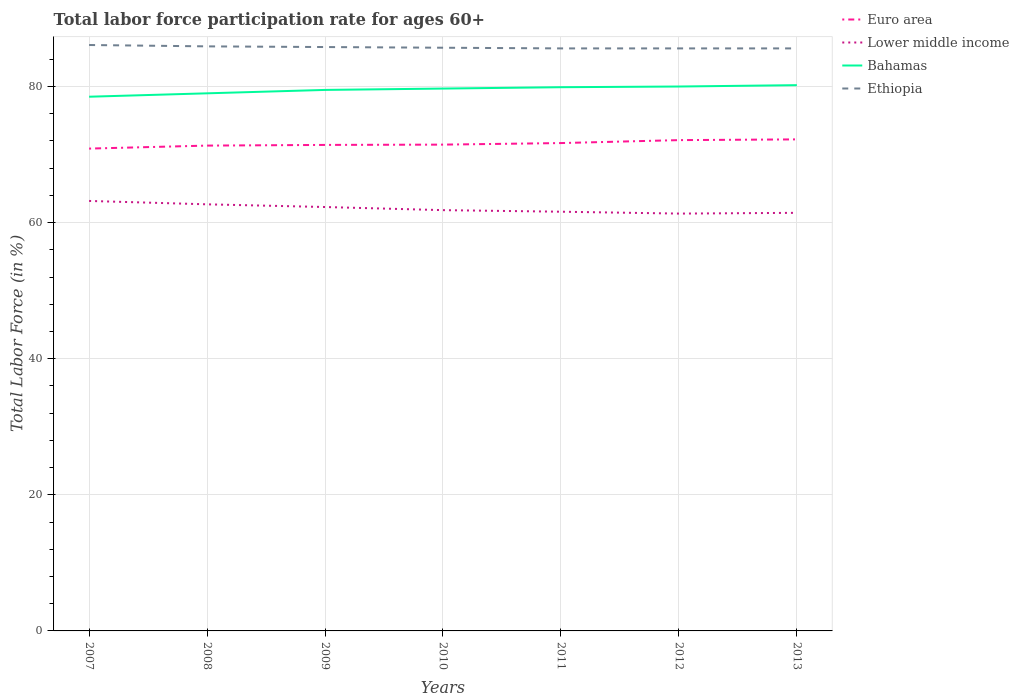How many different coloured lines are there?
Ensure brevity in your answer.  4. Across all years, what is the maximum labor force participation rate in Euro area?
Give a very brief answer. 70.88. In which year was the labor force participation rate in Lower middle income maximum?
Give a very brief answer. 2012. What is the total labor force participation rate in Euro area in the graph?
Your answer should be compact. -0.58. What is the difference between the highest and the second highest labor force participation rate in Bahamas?
Give a very brief answer. 1.7. What is the difference between two consecutive major ticks on the Y-axis?
Ensure brevity in your answer.  20. Are the values on the major ticks of Y-axis written in scientific E-notation?
Provide a succinct answer. No. Does the graph contain grids?
Your response must be concise. Yes. Where does the legend appear in the graph?
Offer a very short reply. Top right. What is the title of the graph?
Keep it short and to the point. Total labor force participation rate for ages 60+. Does "Lesotho" appear as one of the legend labels in the graph?
Your response must be concise. No. What is the label or title of the Y-axis?
Your answer should be very brief. Total Labor Force (in %). What is the Total Labor Force (in %) in Euro area in 2007?
Offer a terse response. 70.88. What is the Total Labor Force (in %) of Lower middle income in 2007?
Give a very brief answer. 63.19. What is the Total Labor Force (in %) of Bahamas in 2007?
Provide a short and direct response. 78.5. What is the Total Labor Force (in %) of Ethiopia in 2007?
Your answer should be very brief. 86.1. What is the Total Labor Force (in %) in Euro area in 2008?
Your response must be concise. 71.32. What is the Total Labor Force (in %) in Lower middle income in 2008?
Your response must be concise. 62.69. What is the Total Labor Force (in %) of Bahamas in 2008?
Provide a short and direct response. 79. What is the Total Labor Force (in %) in Ethiopia in 2008?
Provide a short and direct response. 85.9. What is the Total Labor Force (in %) of Euro area in 2009?
Ensure brevity in your answer.  71.42. What is the Total Labor Force (in %) of Lower middle income in 2009?
Offer a very short reply. 62.29. What is the Total Labor Force (in %) in Bahamas in 2009?
Provide a succinct answer. 79.5. What is the Total Labor Force (in %) in Ethiopia in 2009?
Your answer should be very brief. 85.8. What is the Total Labor Force (in %) of Euro area in 2010?
Offer a terse response. 71.46. What is the Total Labor Force (in %) of Lower middle income in 2010?
Your answer should be compact. 61.83. What is the Total Labor Force (in %) in Bahamas in 2010?
Make the answer very short. 79.7. What is the Total Labor Force (in %) of Ethiopia in 2010?
Provide a succinct answer. 85.7. What is the Total Labor Force (in %) in Euro area in 2011?
Provide a succinct answer. 71.69. What is the Total Labor Force (in %) of Lower middle income in 2011?
Your answer should be compact. 61.6. What is the Total Labor Force (in %) of Bahamas in 2011?
Make the answer very short. 79.9. What is the Total Labor Force (in %) in Ethiopia in 2011?
Your answer should be compact. 85.6. What is the Total Labor Force (in %) in Euro area in 2012?
Provide a succinct answer. 72.12. What is the Total Labor Force (in %) in Lower middle income in 2012?
Provide a succinct answer. 61.33. What is the Total Labor Force (in %) in Ethiopia in 2012?
Provide a succinct answer. 85.6. What is the Total Labor Force (in %) of Euro area in 2013?
Provide a succinct answer. 72.23. What is the Total Labor Force (in %) in Lower middle income in 2013?
Offer a very short reply. 61.44. What is the Total Labor Force (in %) of Bahamas in 2013?
Your answer should be compact. 80.2. What is the Total Labor Force (in %) of Ethiopia in 2013?
Offer a very short reply. 85.6. Across all years, what is the maximum Total Labor Force (in %) in Euro area?
Your answer should be compact. 72.23. Across all years, what is the maximum Total Labor Force (in %) in Lower middle income?
Ensure brevity in your answer.  63.19. Across all years, what is the maximum Total Labor Force (in %) in Bahamas?
Provide a succinct answer. 80.2. Across all years, what is the maximum Total Labor Force (in %) of Ethiopia?
Your answer should be compact. 86.1. Across all years, what is the minimum Total Labor Force (in %) in Euro area?
Offer a terse response. 70.88. Across all years, what is the minimum Total Labor Force (in %) in Lower middle income?
Your response must be concise. 61.33. Across all years, what is the minimum Total Labor Force (in %) of Bahamas?
Ensure brevity in your answer.  78.5. Across all years, what is the minimum Total Labor Force (in %) of Ethiopia?
Provide a short and direct response. 85.6. What is the total Total Labor Force (in %) in Euro area in the graph?
Your response must be concise. 501.12. What is the total Total Labor Force (in %) in Lower middle income in the graph?
Provide a short and direct response. 434.37. What is the total Total Labor Force (in %) in Bahamas in the graph?
Your response must be concise. 556.8. What is the total Total Labor Force (in %) of Ethiopia in the graph?
Ensure brevity in your answer.  600.3. What is the difference between the Total Labor Force (in %) in Euro area in 2007 and that in 2008?
Your answer should be compact. -0.44. What is the difference between the Total Labor Force (in %) of Lower middle income in 2007 and that in 2008?
Ensure brevity in your answer.  0.5. What is the difference between the Total Labor Force (in %) in Bahamas in 2007 and that in 2008?
Ensure brevity in your answer.  -0.5. What is the difference between the Total Labor Force (in %) in Euro area in 2007 and that in 2009?
Provide a succinct answer. -0.54. What is the difference between the Total Labor Force (in %) of Lower middle income in 2007 and that in 2009?
Keep it short and to the point. 0.89. What is the difference between the Total Labor Force (in %) in Bahamas in 2007 and that in 2009?
Give a very brief answer. -1. What is the difference between the Total Labor Force (in %) in Ethiopia in 2007 and that in 2009?
Your response must be concise. 0.3. What is the difference between the Total Labor Force (in %) in Euro area in 2007 and that in 2010?
Keep it short and to the point. -0.58. What is the difference between the Total Labor Force (in %) in Lower middle income in 2007 and that in 2010?
Provide a short and direct response. 1.35. What is the difference between the Total Labor Force (in %) in Bahamas in 2007 and that in 2010?
Make the answer very short. -1.2. What is the difference between the Total Labor Force (in %) in Ethiopia in 2007 and that in 2010?
Give a very brief answer. 0.4. What is the difference between the Total Labor Force (in %) of Euro area in 2007 and that in 2011?
Ensure brevity in your answer.  -0.81. What is the difference between the Total Labor Force (in %) of Lower middle income in 2007 and that in 2011?
Give a very brief answer. 1.58. What is the difference between the Total Labor Force (in %) of Ethiopia in 2007 and that in 2011?
Keep it short and to the point. 0.5. What is the difference between the Total Labor Force (in %) in Euro area in 2007 and that in 2012?
Offer a very short reply. -1.25. What is the difference between the Total Labor Force (in %) in Lower middle income in 2007 and that in 2012?
Your response must be concise. 1.86. What is the difference between the Total Labor Force (in %) of Bahamas in 2007 and that in 2012?
Keep it short and to the point. -1.5. What is the difference between the Total Labor Force (in %) in Euro area in 2007 and that in 2013?
Your response must be concise. -1.35. What is the difference between the Total Labor Force (in %) in Lower middle income in 2007 and that in 2013?
Provide a short and direct response. 1.75. What is the difference between the Total Labor Force (in %) of Bahamas in 2007 and that in 2013?
Offer a very short reply. -1.7. What is the difference between the Total Labor Force (in %) in Ethiopia in 2007 and that in 2013?
Provide a succinct answer. 0.5. What is the difference between the Total Labor Force (in %) in Lower middle income in 2008 and that in 2009?
Your response must be concise. 0.4. What is the difference between the Total Labor Force (in %) of Bahamas in 2008 and that in 2009?
Offer a terse response. -0.5. What is the difference between the Total Labor Force (in %) in Euro area in 2008 and that in 2010?
Offer a terse response. -0.14. What is the difference between the Total Labor Force (in %) in Lower middle income in 2008 and that in 2010?
Your answer should be very brief. 0.85. What is the difference between the Total Labor Force (in %) of Ethiopia in 2008 and that in 2010?
Ensure brevity in your answer.  0.2. What is the difference between the Total Labor Force (in %) in Euro area in 2008 and that in 2011?
Offer a terse response. -0.37. What is the difference between the Total Labor Force (in %) of Lower middle income in 2008 and that in 2011?
Make the answer very short. 1.08. What is the difference between the Total Labor Force (in %) of Bahamas in 2008 and that in 2011?
Offer a terse response. -0.9. What is the difference between the Total Labor Force (in %) of Ethiopia in 2008 and that in 2011?
Your answer should be compact. 0.3. What is the difference between the Total Labor Force (in %) in Euro area in 2008 and that in 2012?
Give a very brief answer. -0.81. What is the difference between the Total Labor Force (in %) of Lower middle income in 2008 and that in 2012?
Offer a terse response. 1.36. What is the difference between the Total Labor Force (in %) in Bahamas in 2008 and that in 2012?
Ensure brevity in your answer.  -1. What is the difference between the Total Labor Force (in %) of Euro area in 2008 and that in 2013?
Ensure brevity in your answer.  -0.91. What is the difference between the Total Labor Force (in %) of Lower middle income in 2008 and that in 2013?
Ensure brevity in your answer.  1.25. What is the difference between the Total Labor Force (in %) of Bahamas in 2008 and that in 2013?
Keep it short and to the point. -1.2. What is the difference between the Total Labor Force (in %) of Ethiopia in 2008 and that in 2013?
Make the answer very short. 0.3. What is the difference between the Total Labor Force (in %) of Euro area in 2009 and that in 2010?
Offer a terse response. -0.04. What is the difference between the Total Labor Force (in %) of Lower middle income in 2009 and that in 2010?
Your response must be concise. 0.46. What is the difference between the Total Labor Force (in %) of Euro area in 2009 and that in 2011?
Make the answer very short. -0.27. What is the difference between the Total Labor Force (in %) of Lower middle income in 2009 and that in 2011?
Ensure brevity in your answer.  0.69. What is the difference between the Total Labor Force (in %) of Euro area in 2009 and that in 2012?
Your response must be concise. -0.7. What is the difference between the Total Labor Force (in %) of Lower middle income in 2009 and that in 2012?
Offer a terse response. 0.97. What is the difference between the Total Labor Force (in %) of Bahamas in 2009 and that in 2012?
Make the answer very short. -0.5. What is the difference between the Total Labor Force (in %) of Ethiopia in 2009 and that in 2012?
Offer a terse response. 0.2. What is the difference between the Total Labor Force (in %) in Euro area in 2009 and that in 2013?
Offer a very short reply. -0.81. What is the difference between the Total Labor Force (in %) in Lower middle income in 2009 and that in 2013?
Give a very brief answer. 0.85. What is the difference between the Total Labor Force (in %) in Euro area in 2010 and that in 2011?
Provide a short and direct response. -0.23. What is the difference between the Total Labor Force (in %) in Lower middle income in 2010 and that in 2011?
Offer a terse response. 0.23. What is the difference between the Total Labor Force (in %) in Bahamas in 2010 and that in 2011?
Ensure brevity in your answer.  -0.2. What is the difference between the Total Labor Force (in %) in Ethiopia in 2010 and that in 2011?
Offer a very short reply. 0.1. What is the difference between the Total Labor Force (in %) in Euro area in 2010 and that in 2012?
Provide a short and direct response. -0.66. What is the difference between the Total Labor Force (in %) in Lower middle income in 2010 and that in 2012?
Your response must be concise. 0.51. What is the difference between the Total Labor Force (in %) in Bahamas in 2010 and that in 2012?
Your answer should be compact. -0.3. What is the difference between the Total Labor Force (in %) in Ethiopia in 2010 and that in 2012?
Your answer should be very brief. 0.1. What is the difference between the Total Labor Force (in %) of Euro area in 2010 and that in 2013?
Your response must be concise. -0.77. What is the difference between the Total Labor Force (in %) in Lower middle income in 2010 and that in 2013?
Keep it short and to the point. 0.4. What is the difference between the Total Labor Force (in %) of Euro area in 2011 and that in 2012?
Provide a succinct answer. -0.43. What is the difference between the Total Labor Force (in %) in Lower middle income in 2011 and that in 2012?
Your response must be concise. 0.28. What is the difference between the Total Labor Force (in %) in Euro area in 2011 and that in 2013?
Ensure brevity in your answer.  -0.54. What is the difference between the Total Labor Force (in %) of Lower middle income in 2011 and that in 2013?
Provide a short and direct response. 0.16. What is the difference between the Total Labor Force (in %) in Bahamas in 2011 and that in 2013?
Provide a short and direct response. -0.3. What is the difference between the Total Labor Force (in %) of Ethiopia in 2011 and that in 2013?
Provide a succinct answer. 0. What is the difference between the Total Labor Force (in %) of Euro area in 2012 and that in 2013?
Make the answer very short. -0.11. What is the difference between the Total Labor Force (in %) of Lower middle income in 2012 and that in 2013?
Your answer should be very brief. -0.11. What is the difference between the Total Labor Force (in %) in Ethiopia in 2012 and that in 2013?
Your response must be concise. 0. What is the difference between the Total Labor Force (in %) in Euro area in 2007 and the Total Labor Force (in %) in Lower middle income in 2008?
Provide a short and direct response. 8.19. What is the difference between the Total Labor Force (in %) of Euro area in 2007 and the Total Labor Force (in %) of Bahamas in 2008?
Your answer should be compact. -8.12. What is the difference between the Total Labor Force (in %) of Euro area in 2007 and the Total Labor Force (in %) of Ethiopia in 2008?
Keep it short and to the point. -15.02. What is the difference between the Total Labor Force (in %) in Lower middle income in 2007 and the Total Labor Force (in %) in Bahamas in 2008?
Offer a terse response. -15.81. What is the difference between the Total Labor Force (in %) of Lower middle income in 2007 and the Total Labor Force (in %) of Ethiopia in 2008?
Offer a terse response. -22.71. What is the difference between the Total Labor Force (in %) in Bahamas in 2007 and the Total Labor Force (in %) in Ethiopia in 2008?
Provide a short and direct response. -7.4. What is the difference between the Total Labor Force (in %) of Euro area in 2007 and the Total Labor Force (in %) of Lower middle income in 2009?
Make the answer very short. 8.59. What is the difference between the Total Labor Force (in %) in Euro area in 2007 and the Total Labor Force (in %) in Bahamas in 2009?
Provide a succinct answer. -8.62. What is the difference between the Total Labor Force (in %) in Euro area in 2007 and the Total Labor Force (in %) in Ethiopia in 2009?
Give a very brief answer. -14.92. What is the difference between the Total Labor Force (in %) of Lower middle income in 2007 and the Total Labor Force (in %) of Bahamas in 2009?
Your answer should be compact. -16.31. What is the difference between the Total Labor Force (in %) of Lower middle income in 2007 and the Total Labor Force (in %) of Ethiopia in 2009?
Provide a short and direct response. -22.61. What is the difference between the Total Labor Force (in %) in Euro area in 2007 and the Total Labor Force (in %) in Lower middle income in 2010?
Your response must be concise. 9.04. What is the difference between the Total Labor Force (in %) of Euro area in 2007 and the Total Labor Force (in %) of Bahamas in 2010?
Make the answer very short. -8.82. What is the difference between the Total Labor Force (in %) of Euro area in 2007 and the Total Labor Force (in %) of Ethiopia in 2010?
Offer a terse response. -14.82. What is the difference between the Total Labor Force (in %) of Lower middle income in 2007 and the Total Labor Force (in %) of Bahamas in 2010?
Your response must be concise. -16.51. What is the difference between the Total Labor Force (in %) in Lower middle income in 2007 and the Total Labor Force (in %) in Ethiopia in 2010?
Give a very brief answer. -22.51. What is the difference between the Total Labor Force (in %) in Euro area in 2007 and the Total Labor Force (in %) in Lower middle income in 2011?
Provide a succinct answer. 9.27. What is the difference between the Total Labor Force (in %) in Euro area in 2007 and the Total Labor Force (in %) in Bahamas in 2011?
Keep it short and to the point. -9.02. What is the difference between the Total Labor Force (in %) in Euro area in 2007 and the Total Labor Force (in %) in Ethiopia in 2011?
Keep it short and to the point. -14.72. What is the difference between the Total Labor Force (in %) of Lower middle income in 2007 and the Total Labor Force (in %) of Bahamas in 2011?
Ensure brevity in your answer.  -16.71. What is the difference between the Total Labor Force (in %) in Lower middle income in 2007 and the Total Labor Force (in %) in Ethiopia in 2011?
Offer a very short reply. -22.41. What is the difference between the Total Labor Force (in %) of Bahamas in 2007 and the Total Labor Force (in %) of Ethiopia in 2011?
Provide a succinct answer. -7.1. What is the difference between the Total Labor Force (in %) in Euro area in 2007 and the Total Labor Force (in %) in Lower middle income in 2012?
Your response must be concise. 9.55. What is the difference between the Total Labor Force (in %) in Euro area in 2007 and the Total Labor Force (in %) in Bahamas in 2012?
Your response must be concise. -9.12. What is the difference between the Total Labor Force (in %) in Euro area in 2007 and the Total Labor Force (in %) in Ethiopia in 2012?
Give a very brief answer. -14.72. What is the difference between the Total Labor Force (in %) of Lower middle income in 2007 and the Total Labor Force (in %) of Bahamas in 2012?
Your answer should be compact. -16.81. What is the difference between the Total Labor Force (in %) of Lower middle income in 2007 and the Total Labor Force (in %) of Ethiopia in 2012?
Make the answer very short. -22.41. What is the difference between the Total Labor Force (in %) of Euro area in 2007 and the Total Labor Force (in %) of Lower middle income in 2013?
Your answer should be compact. 9.44. What is the difference between the Total Labor Force (in %) in Euro area in 2007 and the Total Labor Force (in %) in Bahamas in 2013?
Provide a short and direct response. -9.32. What is the difference between the Total Labor Force (in %) of Euro area in 2007 and the Total Labor Force (in %) of Ethiopia in 2013?
Your answer should be very brief. -14.72. What is the difference between the Total Labor Force (in %) of Lower middle income in 2007 and the Total Labor Force (in %) of Bahamas in 2013?
Offer a very short reply. -17.01. What is the difference between the Total Labor Force (in %) in Lower middle income in 2007 and the Total Labor Force (in %) in Ethiopia in 2013?
Your response must be concise. -22.41. What is the difference between the Total Labor Force (in %) in Euro area in 2008 and the Total Labor Force (in %) in Lower middle income in 2009?
Make the answer very short. 9.03. What is the difference between the Total Labor Force (in %) of Euro area in 2008 and the Total Labor Force (in %) of Bahamas in 2009?
Your answer should be very brief. -8.18. What is the difference between the Total Labor Force (in %) of Euro area in 2008 and the Total Labor Force (in %) of Ethiopia in 2009?
Your answer should be compact. -14.48. What is the difference between the Total Labor Force (in %) of Lower middle income in 2008 and the Total Labor Force (in %) of Bahamas in 2009?
Your answer should be very brief. -16.81. What is the difference between the Total Labor Force (in %) of Lower middle income in 2008 and the Total Labor Force (in %) of Ethiopia in 2009?
Provide a succinct answer. -23.11. What is the difference between the Total Labor Force (in %) in Bahamas in 2008 and the Total Labor Force (in %) in Ethiopia in 2009?
Ensure brevity in your answer.  -6.8. What is the difference between the Total Labor Force (in %) in Euro area in 2008 and the Total Labor Force (in %) in Lower middle income in 2010?
Offer a terse response. 9.48. What is the difference between the Total Labor Force (in %) of Euro area in 2008 and the Total Labor Force (in %) of Bahamas in 2010?
Offer a terse response. -8.38. What is the difference between the Total Labor Force (in %) of Euro area in 2008 and the Total Labor Force (in %) of Ethiopia in 2010?
Your answer should be compact. -14.38. What is the difference between the Total Labor Force (in %) of Lower middle income in 2008 and the Total Labor Force (in %) of Bahamas in 2010?
Provide a short and direct response. -17.01. What is the difference between the Total Labor Force (in %) in Lower middle income in 2008 and the Total Labor Force (in %) in Ethiopia in 2010?
Ensure brevity in your answer.  -23.01. What is the difference between the Total Labor Force (in %) of Bahamas in 2008 and the Total Labor Force (in %) of Ethiopia in 2010?
Keep it short and to the point. -6.7. What is the difference between the Total Labor Force (in %) of Euro area in 2008 and the Total Labor Force (in %) of Lower middle income in 2011?
Ensure brevity in your answer.  9.71. What is the difference between the Total Labor Force (in %) of Euro area in 2008 and the Total Labor Force (in %) of Bahamas in 2011?
Offer a terse response. -8.58. What is the difference between the Total Labor Force (in %) of Euro area in 2008 and the Total Labor Force (in %) of Ethiopia in 2011?
Keep it short and to the point. -14.28. What is the difference between the Total Labor Force (in %) of Lower middle income in 2008 and the Total Labor Force (in %) of Bahamas in 2011?
Keep it short and to the point. -17.21. What is the difference between the Total Labor Force (in %) of Lower middle income in 2008 and the Total Labor Force (in %) of Ethiopia in 2011?
Give a very brief answer. -22.91. What is the difference between the Total Labor Force (in %) in Euro area in 2008 and the Total Labor Force (in %) in Lower middle income in 2012?
Give a very brief answer. 9.99. What is the difference between the Total Labor Force (in %) in Euro area in 2008 and the Total Labor Force (in %) in Bahamas in 2012?
Your answer should be compact. -8.68. What is the difference between the Total Labor Force (in %) of Euro area in 2008 and the Total Labor Force (in %) of Ethiopia in 2012?
Keep it short and to the point. -14.28. What is the difference between the Total Labor Force (in %) in Lower middle income in 2008 and the Total Labor Force (in %) in Bahamas in 2012?
Your response must be concise. -17.31. What is the difference between the Total Labor Force (in %) of Lower middle income in 2008 and the Total Labor Force (in %) of Ethiopia in 2012?
Your response must be concise. -22.91. What is the difference between the Total Labor Force (in %) in Bahamas in 2008 and the Total Labor Force (in %) in Ethiopia in 2012?
Make the answer very short. -6.6. What is the difference between the Total Labor Force (in %) of Euro area in 2008 and the Total Labor Force (in %) of Lower middle income in 2013?
Your answer should be compact. 9.88. What is the difference between the Total Labor Force (in %) in Euro area in 2008 and the Total Labor Force (in %) in Bahamas in 2013?
Your answer should be very brief. -8.88. What is the difference between the Total Labor Force (in %) of Euro area in 2008 and the Total Labor Force (in %) of Ethiopia in 2013?
Ensure brevity in your answer.  -14.28. What is the difference between the Total Labor Force (in %) in Lower middle income in 2008 and the Total Labor Force (in %) in Bahamas in 2013?
Keep it short and to the point. -17.51. What is the difference between the Total Labor Force (in %) in Lower middle income in 2008 and the Total Labor Force (in %) in Ethiopia in 2013?
Provide a short and direct response. -22.91. What is the difference between the Total Labor Force (in %) of Euro area in 2009 and the Total Labor Force (in %) of Lower middle income in 2010?
Provide a succinct answer. 9.58. What is the difference between the Total Labor Force (in %) in Euro area in 2009 and the Total Labor Force (in %) in Bahamas in 2010?
Offer a very short reply. -8.28. What is the difference between the Total Labor Force (in %) of Euro area in 2009 and the Total Labor Force (in %) of Ethiopia in 2010?
Provide a succinct answer. -14.28. What is the difference between the Total Labor Force (in %) of Lower middle income in 2009 and the Total Labor Force (in %) of Bahamas in 2010?
Your answer should be very brief. -17.41. What is the difference between the Total Labor Force (in %) in Lower middle income in 2009 and the Total Labor Force (in %) in Ethiopia in 2010?
Ensure brevity in your answer.  -23.41. What is the difference between the Total Labor Force (in %) in Euro area in 2009 and the Total Labor Force (in %) in Lower middle income in 2011?
Your answer should be very brief. 9.81. What is the difference between the Total Labor Force (in %) of Euro area in 2009 and the Total Labor Force (in %) of Bahamas in 2011?
Offer a very short reply. -8.48. What is the difference between the Total Labor Force (in %) in Euro area in 2009 and the Total Labor Force (in %) in Ethiopia in 2011?
Offer a terse response. -14.18. What is the difference between the Total Labor Force (in %) of Lower middle income in 2009 and the Total Labor Force (in %) of Bahamas in 2011?
Your answer should be very brief. -17.61. What is the difference between the Total Labor Force (in %) of Lower middle income in 2009 and the Total Labor Force (in %) of Ethiopia in 2011?
Your answer should be very brief. -23.31. What is the difference between the Total Labor Force (in %) in Bahamas in 2009 and the Total Labor Force (in %) in Ethiopia in 2011?
Make the answer very short. -6.1. What is the difference between the Total Labor Force (in %) of Euro area in 2009 and the Total Labor Force (in %) of Lower middle income in 2012?
Your answer should be compact. 10.09. What is the difference between the Total Labor Force (in %) of Euro area in 2009 and the Total Labor Force (in %) of Bahamas in 2012?
Offer a very short reply. -8.58. What is the difference between the Total Labor Force (in %) of Euro area in 2009 and the Total Labor Force (in %) of Ethiopia in 2012?
Provide a short and direct response. -14.18. What is the difference between the Total Labor Force (in %) of Lower middle income in 2009 and the Total Labor Force (in %) of Bahamas in 2012?
Keep it short and to the point. -17.71. What is the difference between the Total Labor Force (in %) in Lower middle income in 2009 and the Total Labor Force (in %) in Ethiopia in 2012?
Offer a very short reply. -23.31. What is the difference between the Total Labor Force (in %) in Euro area in 2009 and the Total Labor Force (in %) in Lower middle income in 2013?
Your answer should be compact. 9.98. What is the difference between the Total Labor Force (in %) in Euro area in 2009 and the Total Labor Force (in %) in Bahamas in 2013?
Provide a short and direct response. -8.78. What is the difference between the Total Labor Force (in %) of Euro area in 2009 and the Total Labor Force (in %) of Ethiopia in 2013?
Give a very brief answer. -14.18. What is the difference between the Total Labor Force (in %) of Lower middle income in 2009 and the Total Labor Force (in %) of Bahamas in 2013?
Ensure brevity in your answer.  -17.91. What is the difference between the Total Labor Force (in %) in Lower middle income in 2009 and the Total Labor Force (in %) in Ethiopia in 2013?
Keep it short and to the point. -23.31. What is the difference between the Total Labor Force (in %) of Euro area in 2010 and the Total Labor Force (in %) of Lower middle income in 2011?
Give a very brief answer. 9.86. What is the difference between the Total Labor Force (in %) of Euro area in 2010 and the Total Labor Force (in %) of Bahamas in 2011?
Your answer should be compact. -8.44. What is the difference between the Total Labor Force (in %) in Euro area in 2010 and the Total Labor Force (in %) in Ethiopia in 2011?
Keep it short and to the point. -14.14. What is the difference between the Total Labor Force (in %) in Lower middle income in 2010 and the Total Labor Force (in %) in Bahamas in 2011?
Offer a terse response. -18.07. What is the difference between the Total Labor Force (in %) in Lower middle income in 2010 and the Total Labor Force (in %) in Ethiopia in 2011?
Offer a terse response. -23.77. What is the difference between the Total Labor Force (in %) of Bahamas in 2010 and the Total Labor Force (in %) of Ethiopia in 2011?
Keep it short and to the point. -5.9. What is the difference between the Total Labor Force (in %) of Euro area in 2010 and the Total Labor Force (in %) of Lower middle income in 2012?
Give a very brief answer. 10.13. What is the difference between the Total Labor Force (in %) in Euro area in 2010 and the Total Labor Force (in %) in Bahamas in 2012?
Give a very brief answer. -8.54. What is the difference between the Total Labor Force (in %) in Euro area in 2010 and the Total Labor Force (in %) in Ethiopia in 2012?
Offer a very short reply. -14.14. What is the difference between the Total Labor Force (in %) in Lower middle income in 2010 and the Total Labor Force (in %) in Bahamas in 2012?
Your answer should be very brief. -18.17. What is the difference between the Total Labor Force (in %) in Lower middle income in 2010 and the Total Labor Force (in %) in Ethiopia in 2012?
Make the answer very short. -23.77. What is the difference between the Total Labor Force (in %) of Bahamas in 2010 and the Total Labor Force (in %) of Ethiopia in 2012?
Your response must be concise. -5.9. What is the difference between the Total Labor Force (in %) of Euro area in 2010 and the Total Labor Force (in %) of Lower middle income in 2013?
Offer a terse response. 10.02. What is the difference between the Total Labor Force (in %) in Euro area in 2010 and the Total Labor Force (in %) in Bahamas in 2013?
Make the answer very short. -8.74. What is the difference between the Total Labor Force (in %) of Euro area in 2010 and the Total Labor Force (in %) of Ethiopia in 2013?
Provide a short and direct response. -14.14. What is the difference between the Total Labor Force (in %) of Lower middle income in 2010 and the Total Labor Force (in %) of Bahamas in 2013?
Offer a terse response. -18.37. What is the difference between the Total Labor Force (in %) in Lower middle income in 2010 and the Total Labor Force (in %) in Ethiopia in 2013?
Offer a very short reply. -23.77. What is the difference between the Total Labor Force (in %) in Euro area in 2011 and the Total Labor Force (in %) in Lower middle income in 2012?
Your response must be concise. 10.36. What is the difference between the Total Labor Force (in %) of Euro area in 2011 and the Total Labor Force (in %) of Bahamas in 2012?
Offer a terse response. -8.31. What is the difference between the Total Labor Force (in %) of Euro area in 2011 and the Total Labor Force (in %) of Ethiopia in 2012?
Offer a very short reply. -13.91. What is the difference between the Total Labor Force (in %) in Lower middle income in 2011 and the Total Labor Force (in %) in Bahamas in 2012?
Make the answer very short. -18.4. What is the difference between the Total Labor Force (in %) of Lower middle income in 2011 and the Total Labor Force (in %) of Ethiopia in 2012?
Keep it short and to the point. -24. What is the difference between the Total Labor Force (in %) of Bahamas in 2011 and the Total Labor Force (in %) of Ethiopia in 2012?
Provide a succinct answer. -5.7. What is the difference between the Total Labor Force (in %) in Euro area in 2011 and the Total Labor Force (in %) in Lower middle income in 2013?
Your response must be concise. 10.25. What is the difference between the Total Labor Force (in %) in Euro area in 2011 and the Total Labor Force (in %) in Bahamas in 2013?
Your answer should be very brief. -8.51. What is the difference between the Total Labor Force (in %) of Euro area in 2011 and the Total Labor Force (in %) of Ethiopia in 2013?
Make the answer very short. -13.91. What is the difference between the Total Labor Force (in %) in Lower middle income in 2011 and the Total Labor Force (in %) in Bahamas in 2013?
Your response must be concise. -18.6. What is the difference between the Total Labor Force (in %) of Lower middle income in 2011 and the Total Labor Force (in %) of Ethiopia in 2013?
Keep it short and to the point. -24. What is the difference between the Total Labor Force (in %) of Euro area in 2012 and the Total Labor Force (in %) of Lower middle income in 2013?
Provide a short and direct response. 10.68. What is the difference between the Total Labor Force (in %) of Euro area in 2012 and the Total Labor Force (in %) of Bahamas in 2013?
Your answer should be very brief. -8.08. What is the difference between the Total Labor Force (in %) in Euro area in 2012 and the Total Labor Force (in %) in Ethiopia in 2013?
Offer a very short reply. -13.48. What is the difference between the Total Labor Force (in %) in Lower middle income in 2012 and the Total Labor Force (in %) in Bahamas in 2013?
Offer a terse response. -18.87. What is the difference between the Total Labor Force (in %) of Lower middle income in 2012 and the Total Labor Force (in %) of Ethiopia in 2013?
Give a very brief answer. -24.27. What is the average Total Labor Force (in %) of Euro area per year?
Your answer should be very brief. 71.59. What is the average Total Labor Force (in %) in Lower middle income per year?
Give a very brief answer. 62.05. What is the average Total Labor Force (in %) of Bahamas per year?
Offer a terse response. 79.54. What is the average Total Labor Force (in %) of Ethiopia per year?
Ensure brevity in your answer.  85.76. In the year 2007, what is the difference between the Total Labor Force (in %) of Euro area and Total Labor Force (in %) of Lower middle income?
Provide a short and direct response. 7.69. In the year 2007, what is the difference between the Total Labor Force (in %) in Euro area and Total Labor Force (in %) in Bahamas?
Your answer should be compact. -7.62. In the year 2007, what is the difference between the Total Labor Force (in %) of Euro area and Total Labor Force (in %) of Ethiopia?
Offer a terse response. -15.22. In the year 2007, what is the difference between the Total Labor Force (in %) of Lower middle income and Total Labor Force (in %) of Bahamas?
Your answer should be compact. -15.31. In the year 2007, what is the difference between the Total Labor Force (in %) in Lower middle income and Total Labor Force (in %) in Ethiopia?
Ensure brevity in your answer.  -22.91. In the year 2007, what is the difference between the Total Labor Force (in %) of Bahamas and Total Labor Force (in %) of Ethiopia?
Keep it short and to the point. -7.6. In the year 2008, what is the difference between the Total Labor Force (in %) of Euro area and Total Labor Force (in %) of Lower middle income?
Keep it short and to the point. 8.63. In the year 2008, what is the difference between the Total Labor Force (in %) in Euro area and Total Labor Force (in %) in Bahamas?
Ensure brevity in your answer.  -7.68. In the year 2008, what is the difference between the Total Labor Force (in %) of Euro area and Total Labor Force (in %) of Ethiopia?
Your answer should be very brief. -14.58. In the year 2008, what is the difference between the Total Labor Force (in %) in Lower middle income and Total Labor Force (in %) in Bahamas?
Offer a very short reply. -16.31. In the year 2008, what is the difference between the Total Labor Force (in %) of Lower middle income and Total Labor Force (in %) of Ethiopia?
Offer a very short reply. -23.21. In the year 2008, what is the difference between the Total Labor Force (in %) of Bahamas and Total Labor Force (in %) of Ethiopia?
Make the answer very short. -6.9. In the year 2009, what is the difference between the Total Labor Force (in %) of Euro area and Total Labor Force (in %) of Lower middle income?
Offer a terse response. 9.13. In the year 2009, what is the difference between the Total Labor Force (in %) in Euro area and Total Labor Force (in %) in Bahamas?
Your answer should be very brief. -8.08. In the year 2009, what is the difference between the Total Labor Force (in %) in Euro area and Total Labor Force (in %) in Ethiopia?
Give a very brief answer. -14.38. In the year 2009, what is the difference between the Total Labor Force (in %) of Lower middle income and Total Labor Force (in %) of Bahamas?
Provide a succinct answer. -17.21. In the year 2009, what is the difference between the Total Labor Force (in %) of Lower middle income and Total Labor Force (in %) of Ethiopia?
Your answer should be compact. -23.51. In the year 2010, what is the difference between the Total Labor Force (in %) in Euro area and Total Labor Force (in %) in Lower middle income?
Ensure brevity in your answer.  9.63. In the year 2010, what is the difference between the Total Labor Force (in %) in Euro area and Total Labor Force (in %) in Bahamas?
Your response must be concise. -8.24. In the year 2010, what is the difference between the Total Labor Force (in %) of Euro area and Total Labor Force (in %) of Ethiopia?
Provide a succinct answer. -14.24. In the year 2010, what is the difference between the Total Labor Force (in %) of Lower middle income and Total Labor Force (in %) of Bahamas?
Offer a terse response. -17.87. In the year 2010, what is the difference between the Total Labor Force (in %) of Lower middle income and Total Labor Force (in %) of Ethiopia?
Your answer should be very brief. -23.87. In the year 2011, what is the difference between the Total Labor Force (in %) in Euro area and Total Labor Force (in %) in Lower middle income?
Make the answer very short. 10.09. In the year 2011, what is the difference between the Total Labor Force (in %) of Euro area and Total Labor Force (in %) of Bahamas?
Offer a very short reply. -8.21. In the year 2011, what is the difference between the Total Labor Force (in %) in Euro area and Total Labor Force (in %) in Ethiopia?
Your answer should be compact. -13.91. In the year 2011, what is the difference between the Total Labor Force (in %) of Lower middle income and Total Labor Force (in %) of Bahamas?
Your answer should be compact. -18.3. In the year 2011, what is the difference between the Total Labor Force (in %) of Lower middle income and Total Labor Force (in %) of Ethiopia?
Ensure brevity in your answer.  -24. In the year 2012, what is the difference between the Total Labor Force (in %) in Euro area and Total Labor Force (in %) in Lower middle income?
Your response must be concise. 10.8. In the year 2012, what is the difference between the Total Labor Force (in %) of Euro area and Total Labor Force (in %) of Bahamas?
Keep it short and to the point. -7.88. In the year 2012, what is the difference between the Total Labor Force (in %) in Euro area and Total Labor Force (in %) in Ethiopia?
Your response must be concise. -13.48. In the year 2012, what is the difference between the Total Labor Force (in %) in Lower middle income and Total Labor Force (in %) in Bahamas?
Provide a short and direct response. -18.67. In the year 2012, what is the difference between the Total Labor Force (in %) in Lower middle income and Total Labor Force (in %) in Ethiopia?
Keep it short and to the point. -24.27. In the year 2012, what is the difference between the Total Labor Force (in %) in Bahamas and Total Labor Force (in %) in Ethiopia?
Give a very brief answer. -5.6. In the year 2013, what is the difference between the Total Labor Force (in %) in Euro area and Total Labor Force (in %) in Lower middle income?
Offer a very short reply. 10.79. In the year 2013, what is the difference between the Total Labor Force (in %) in Euro area and Total Labor Force (in %) in Bahamas?
Your answer should be compact. -7.97. In the year 2013, what is the difference between the Total Labor Force (in %) in Euro area and Total Labor Force (in %) in Ethiopia?
Give a very brief answer. -13.37. In the year 2013, what is the difference between the Total Labor Force (in %) of Lower middle income and Total Labor Force (in %) of Bahamas?
Offer a very short reply. -18.76. In the year 2013, what is the difference between the Total Labor Force (in %) in Lower middle income and Total Labor Force (in %) in Ethiopia?
Offer a very short reply. -24.16. What is the ratio of the Total Labor Force (in %) in Lower middle income in 2007 to that in 2008?
Ensure brevity in your answer.  1.01. What is the ratio of the Total Labor Force (in %) in Bahamas in 2007 to that in 2008?
Your answer should be compact. 0.99. What is the ratio of the Total Labor Force (in %) in Lower middle income in 2007 to that in 2009?
Keep it short and to the point. 1.01. What is the ratio of the Total Labor Force (in %) in Bahamas in 2007 to that in 2009?
Provide a succinct answer. 0.99. What is the ratio of the Total Labor Force (in %) in Euro area in 2007 to that in 2010?
Offer a terse response. 0.99. What is the ratio of the Total Labor Force (in %) in Lower middle income in 2007 to that in 2010?
Provide a succinct answer. 1.02. What is the ratio of the Total Labor Force (in %) in Bahamas in 2007 to that in 2010?
Provide a short and direct response. 0.98. What is the ratio of the Total Labor Force (in %) in Euro area in 2007 to that in 2011?
Make the answer very short. 0.99. What is the ratio of the Total Labor Force (in %) of Lower middle income in 2007 to that in 2011?
Make the answer very short. 1.03. What is the ratio of the Total Labor Force (in %) of Bahamas in 2007 to that in 2011?
Make the answer very short. 0.98. What is the ratio of the Total Labor Force (in %) in Ethiopia in 2007 to that in 2011?
Give a very brief answer. 1.01. What is the ratio of the Total Labor Force (in %) in Euro area in 2007 to that in 2012?
Provide a succinct answer. 0.98. What is the ratio of the Total Labor Force (in %) of Lower middle income in 2007 to that in 2012?
Your response must be concise. 1.03. What is the ratio of the Total Labor Force (in %) in Bahamas in 2007 to that in 2012?
Your response must be concise. 0.98. What is the ratio of the Total Labor Force (in %) in Ethiopia in 2007 to that in 2012?
Provide a short and direct response. 1.01. What is the ratio of the Total Labor Force (in %) in Euro area in 2007 to that in 2013?
Your answer should be very brief. 0.98. What is the ratio of the Total Labor Force (in %) in Lower middle income in 2007 to that in 2013?
Your response must be concise. 1.03. What is the ratio of the Total Labor Force (in %) in Bahamas in 2007 to that in 2013?
Give a very brief answer. 0.98. What is the ratio of the Total Labor Force (in %) of Ethiopia in 2007 to that in 2013?
Offer a very short reply. 1.01. What is the ratio of the Total Labor Force (in %) in Euro area in 2008 to that in 2009?
Your answer should be compact. 1. What is the ratio of the Total Labor Force (in %) in Lower middle income in 2008 to that in 2009?
Offer a terse response. 1.01. What is the ratio of the Total Labor Force (in %) in Euro area in 2008 to that in 2010?
Offer a terse response. 1. What is the ratio of the Total Labor Force (in %) in Lower middle income in 2008 to that in 2010?
Your answer should be compact. 1.01. What is the ratio of the Total Labor Force (in %) of Euro area in 2008 to that in 2011?
Make the answer very short. 0.99. What is the ratio of the Total Labor Force (in %) of Lower middle income in 2008 to that in 2011?
Your answer should be compact. 1.02. What is the ratio of the Total Labor Force (in %) of Bahamas in 2008 to that in 2011?
Keep it short and to the point. 0.99. What is the ratio of the Total Labor Force (in %) of Euro area in 2008 to that in 2012?
Keep it short and to the point. 0.99. What is the ratio of the Total Labor Force (in %) in Lower middle income in 2008 to that in 2012?
Your answer should be very brief. 1.02. What is the ratio of the Total Labor Force (in %) of Bahamas in 2008 to that in 2012?
Your answer should be compact. 0.99. What is the ratio of the Total Labor Force (in %) in Euro area in 2008 to that in 2013?
Your response must be concise. 0.99. What is the ratio of the Total Labor Force (in %) in Lower middle income in 2008 to that in 2013?
Offer a very short reply. 1.02. What is the ratio of the Total Labor Force (in %) in Ethiopia in 2008 to that in 2013?
Provide a short and direct response. 1. What is the ratio of the Total Labor Force (in %) of Euro area in 2009 to that in 2010?
Provide a succinct answer. 1. What is the ratio of the Total Labor Force (in %) of Lower middle income in 2009 to that in 2010?
Your answer should be compact. 1.01. What is the ratio of the Total Labor Force (in %) in Bahamas in 2009 to that in 2010?
Keep it short and to the point. 1. What is the ratio of the Total Labor Force (in %) in Lower middle income in 2009 to that in 2011?
Give a very brief answer. 1.01. What is the ratio of the Total Labor Force (in %) in Bahamas in 2009 to that in 2011?
Your response must be concise. 0.99. What is the ratio of the Total Labor Force (in %) of Euro area in 2009 to that in 2012?
Your answer should be very brief. 0.99. What is the ratio of the Total Labor Force (in %) in Lower middle income in 2009 to that in 2012?
Provide a short and direct response. 1.02. What is the ratio of the Total Labor Force (in %) in Euro area in 2009 to that in 2013?
Your answer should be compact. 0.99. What is the ratio of the Total Labor Force (in %) in Lower middle income in 2009 to that in 2013?
Your answer should be compact. 1.01. What is the ratio of the Total Labor Force (in %) in Bahamas in 2009 to that in 2013?
Your answer should be very brief. 0.99. What is the ratio of the Total Labor Force (in %) in Euro area in 2010 to that in 2011?
Offer a very short reply. 1. What is the ratio of the Total Labor Force (in %) of Ethiopia in 2010 to that in 2011?
Provide a succinct answer. 1. What is the ratio of the Total Labor Force (in %) in Euro area in 2010 to that in 2012?
Offer a terse response. 0.99. What is the ratio of the Total Labor Force (in %) in Lower middle income in 2010 to that in 2012?
Offer a terse response. 1.01. What is the ratio of the Total Labor Force (in %) of Euro area in 2010 to that in 2013?
Your response must be concise. 0.99. What is the ratio of the Total Labor Force (in %) in Lower middle income in 2010 to that in 2013?
Keep it short and to the point. 1.01. What is the ratio of the Total Labor Force (in %) in Bahamas in 2010 to that in 2013?
Your answer should be very brief. 0.99. What is the ratio of the Total Labor Force (in %) of Bahamas in 2011 to that in 2012?
Make the answer very short. 1. What is the ratio of the Total Labor Force (in %) of Ethiopia in 2011 to that in 2012?
Your answer should be very brief. 1. What is the ratio of the Total Labor Force (in %) of Euro area in 2011 to that in 2013?
Ensure brevity in your answer.  0.99. What is the ratio of the Total Labor Force (in %) in Ethiopia in 2011 to that in 2013?
Make the answer very short. 1. What is the ratio of the Total Labor Force (in %) in Lower middle income in 2012 to that in 2013?
Provide a succinct answer. 1. What is the ratio of the Total Labor Force (in %) in Bahamas in 2012 to that in 2013?
Make the answer very short. 1. What is the difference between the highest and the second highest Total Labor Force (in %) of Euro area?
Give a very brief answer. 0.11. What is the difference between the highest and the second highest Total Labor Force (in %) of Lower middle income?
Keep it short and to the point. 0.5. What is the difference between the highest and the second highest Total Labor Force (in %) in Ethiopia?
Make the answer very short. 0.2. What is the difference between the highest and the lowest Total Labor Force (in %) of Euro area?
Ensure brevity in your answer.  1.35. What is the difference between the highest and the lowest Total Labor Force (in %) of Lower middle income?
Your response must be concise. 1.86. What is the difference between the highest and the lowest Total Labor Force (in %) in Bahamas?
Your answer should be very brief. 1.7. 